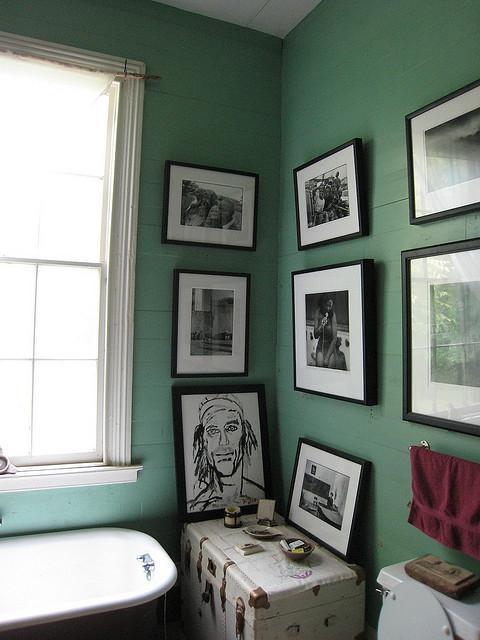How many pictures are on the wall?
Give a very brief answer. 8. 